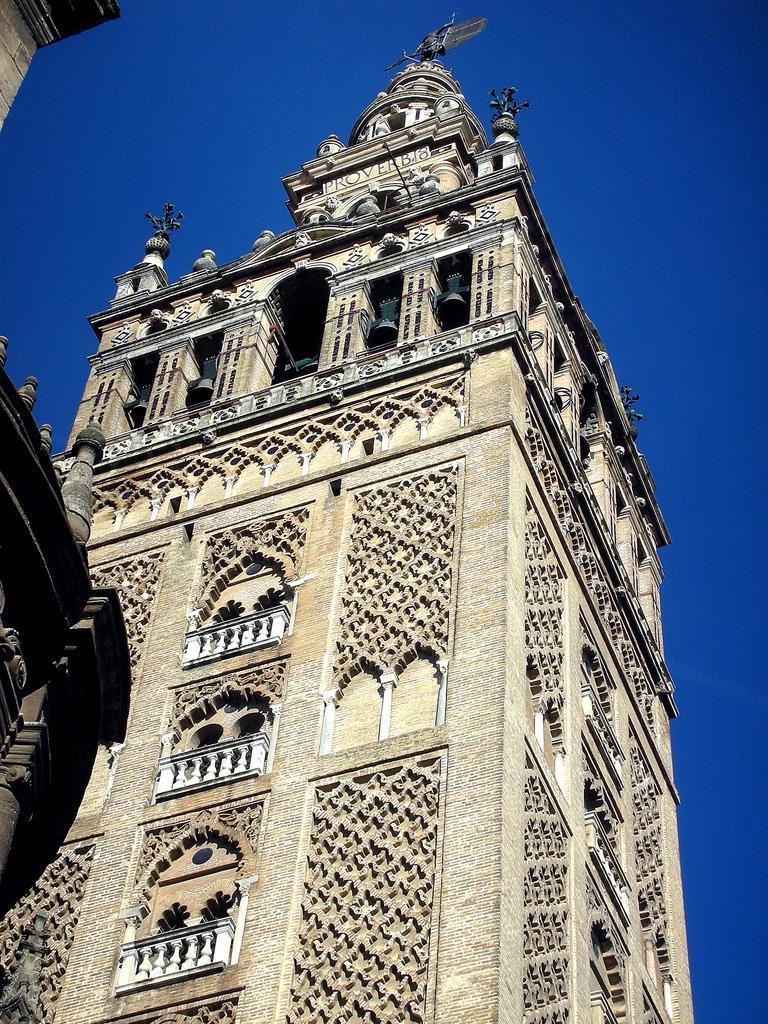Please provide a concise description of this image. In this image we can see the buildings, at the top of the building we can see a statue, there are some windows and grille, also we can see the sky. 